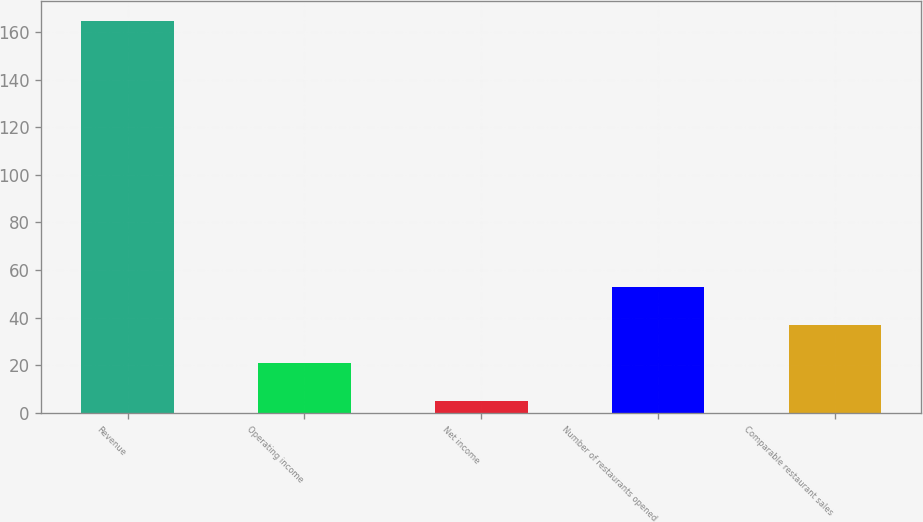Convert chart to OTSL. <chart><loc_0><loc_0><loc_500><loc_500><bar_chart><fcel>Revenue<fcel>Operating income<fcel>Net income<fcel>Number of restaurants opened<fcel>Comparable restaurant sales<nl><fcel>164.7<fcel>21.06<fcel>5.1<fcel>52.98<fcel>37.02<nl></chart> 